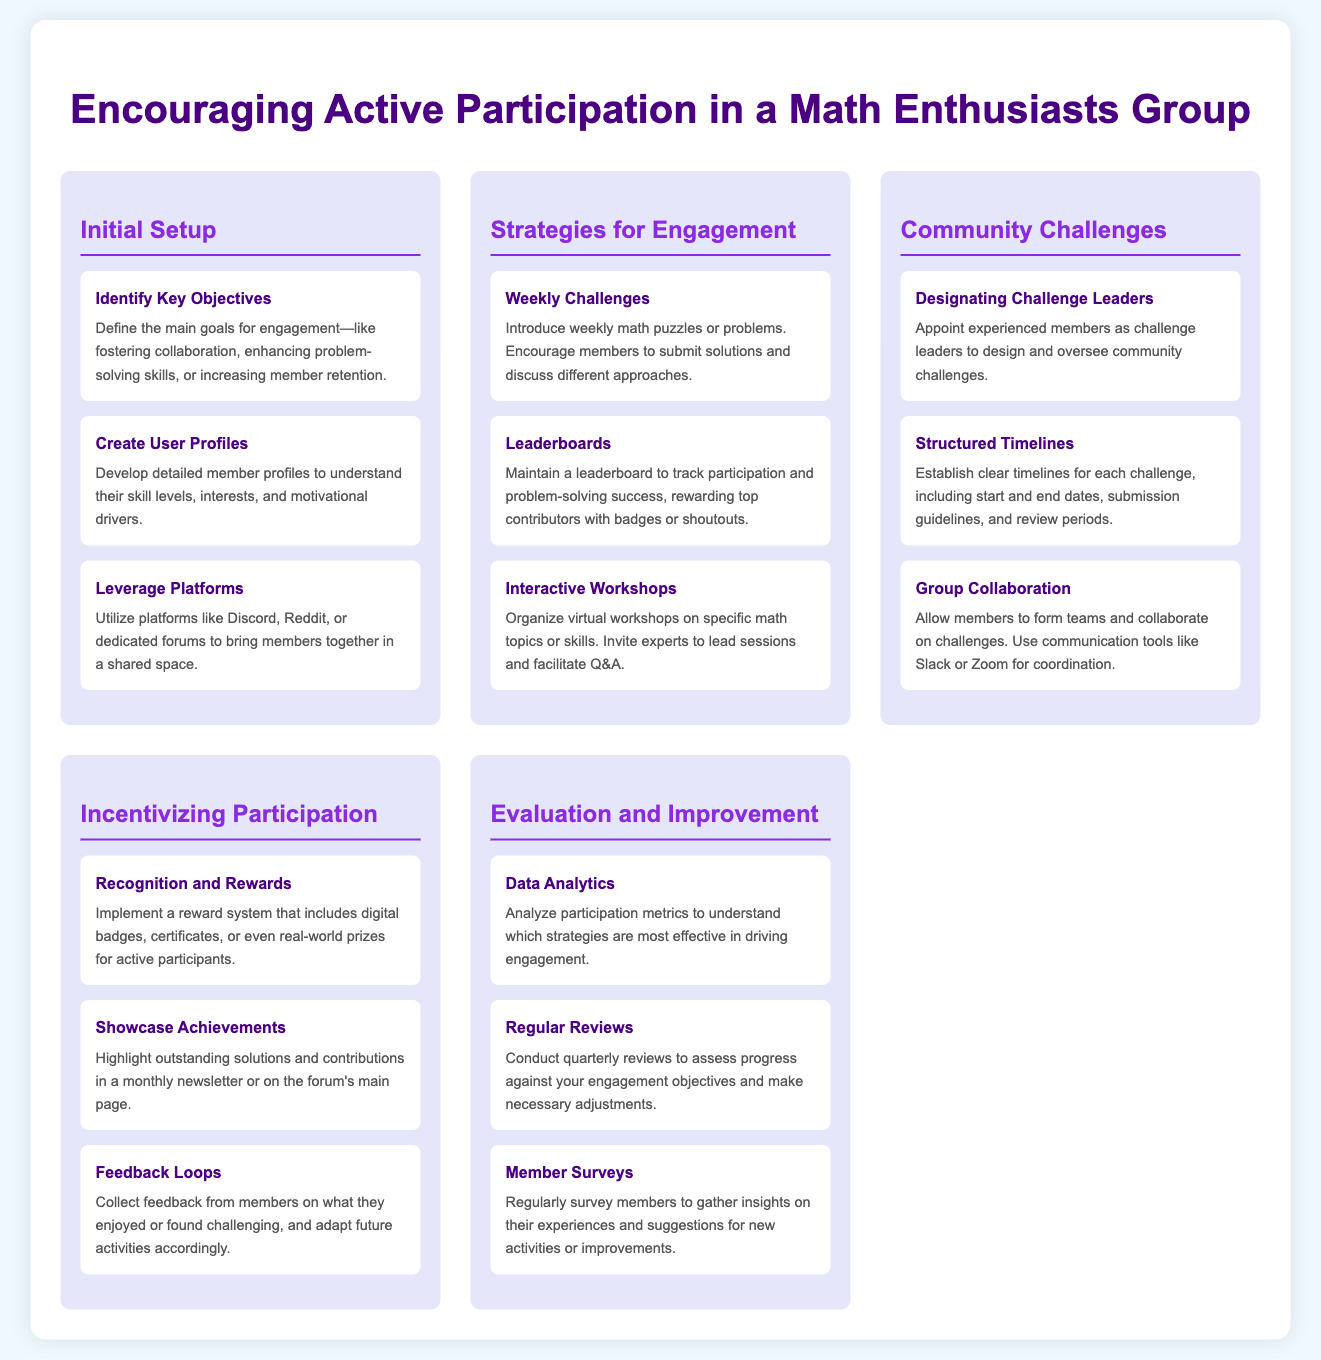what are the key objectives for engagement? The key objectives for engagement are defined in the "Initial Setup" section and include fostering collaboration, enhancing problem-solving skills, or increasing member retention.
Answer: fostering collaboration, enhancing problem-solving skills, increasing member retention which strategy introduces weekly math puzzles? The strategy that introduces weekly math puzzles is found in the "Strategies for Engagement" section.
Answer: Weekly Challenges who is responsible for designing community challenges? The responsibility for designing community challenges is assigned to experienced members in the "Community Challenges" section.
Answer: challenge leaders what is one method to incentivize participation? A method to incentivize participation is detailed in the "Incentivizing Participation" section and includes implementing a reward system.
Answer: reward system how often should regular reviews be conducted? The frequency of regular reviews is mentioned in the "Evaluation and Improvement" section, indicating these should be conducted quarterly.
Answer: quarterly what is analyzed to understand effective strategies? The analysis to understand effective strategies is performed on participation metrics as noted in the "Evaluation and Improvement" section.
Answer: participation metrics 